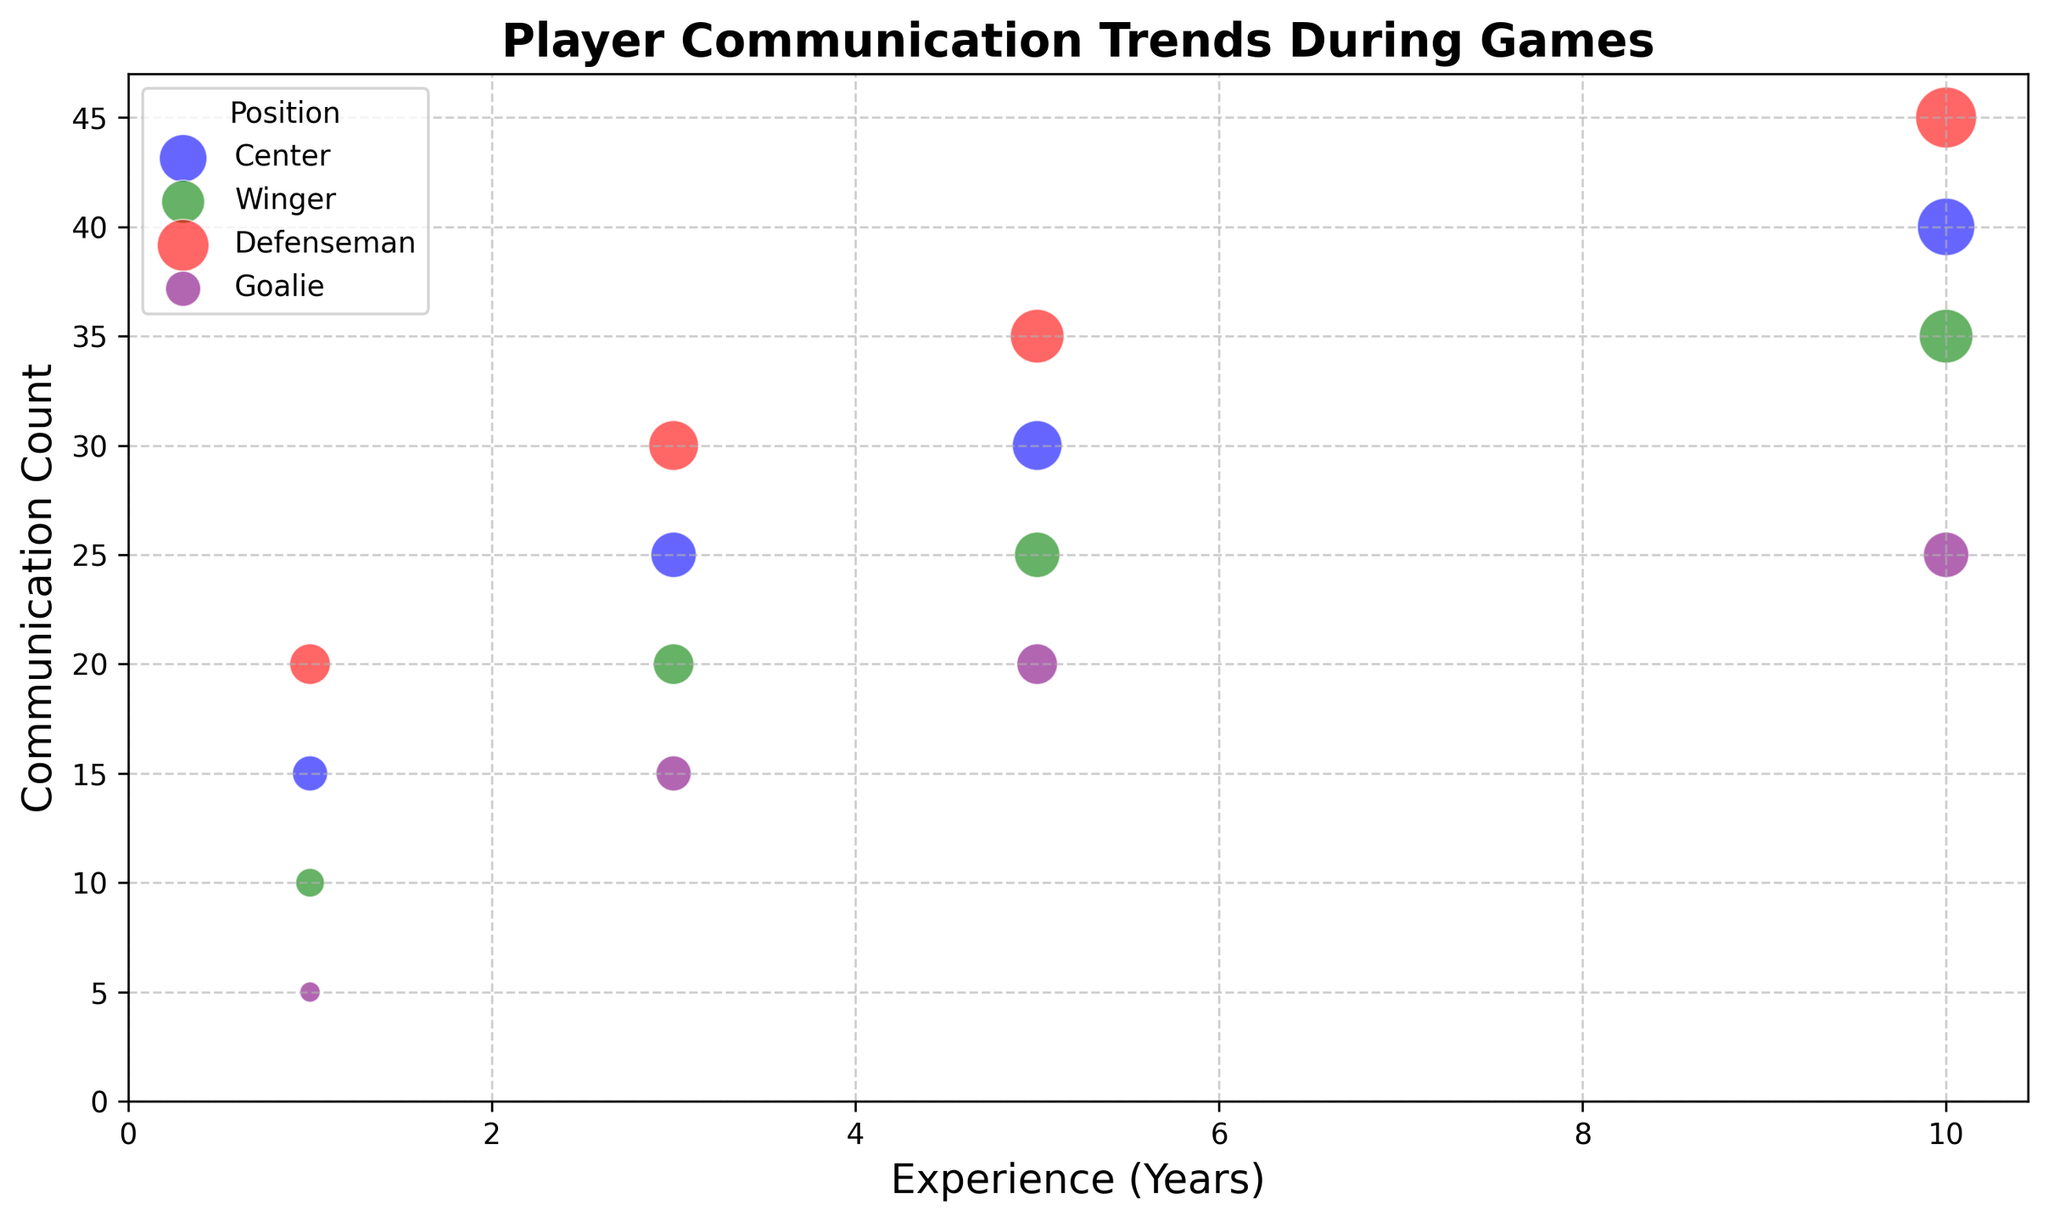Which position shows the highest communication count for players with 3 years of experience? The figure shows separate colored bubbles for each position. By looking at the y-axis value for players with 3 years of experience, the highest communication count is represented by the red bubble, which corresponds to Defenseman.
Answer: Defenseman How does the communication count trend for centers change with increasing experience? Observing the blue bubbles (Centers), we see an upward trajectory. For 1 year, it counts 15; for 3 years, it counts 25; for 5 years, it counts 30; and for 10 years, it counts 40. The trend shows a consistent increase in communication counts as experience increases.
Answer: Increases Which position has the smallest bubble size across all experience levels? Bubble size represents the communication count. By examining the smallest bubbles visually, the purple-colored bubbles (Goalie) show the smallest sizes compared to other positions.
Answer: Goalie What is the total communication count for centers with 1 and 3 years of experience combined? Adding the communication counts for centers: 15 (1 year) and 25 (3 years) gives a total of 40.
Answer: 40 Which position has the highest communication count for players with 10 years of experience? Looking at the measurement on the y-axis for players with 10 years of experience, the highest counts are represented by the red bubble (Defenseman) at 45.
Answer: Defenseman Is the communication count for wingers with 5 years of experience higher or lower than for centers with the same experience? By comparing the communication counts on the y-axis, centers with 5 years have a count of 30, while wingers have a count of 25. The count for wingers is lower.
Answer: Lower What is the average communication count for goalies across all experience levels displayed? Summing communication counts for goalies (5 + 15 + 20 + 25 = 65) and dividing by the number of data points (4) gives an average: 65/4 = 16.25.
Answer: 16.25 Which position has a green-colored bubble and what's the trend in their communication count as experience increases? The green bubbles represent wingers. By observing the y-axis for green bubbles across experience levels, we see: 10 (1 year), 20 (3 years), 25 (5 years), and 35 (10 years). The trend shows an upward increase in communication count as experience increases.
Answer: Winger, increases How does the communication count for defensemen with 5 years of experience compare to that of centers with the same experience? The y-axis values for defensemen (35) and centers (30) for 5 years of experience show that defensemen have a higher communication count.
Answer: Higher Is there a significant difference in communication counts between centers and wingers with 10 years of experience? Comparing the y-axis values, centers have a communication count of 40 whereas wingers have a count of 35. While centers have a higher count, the difference is 5, which might not be considered significant depending on the context.
Answer: No significant difference 